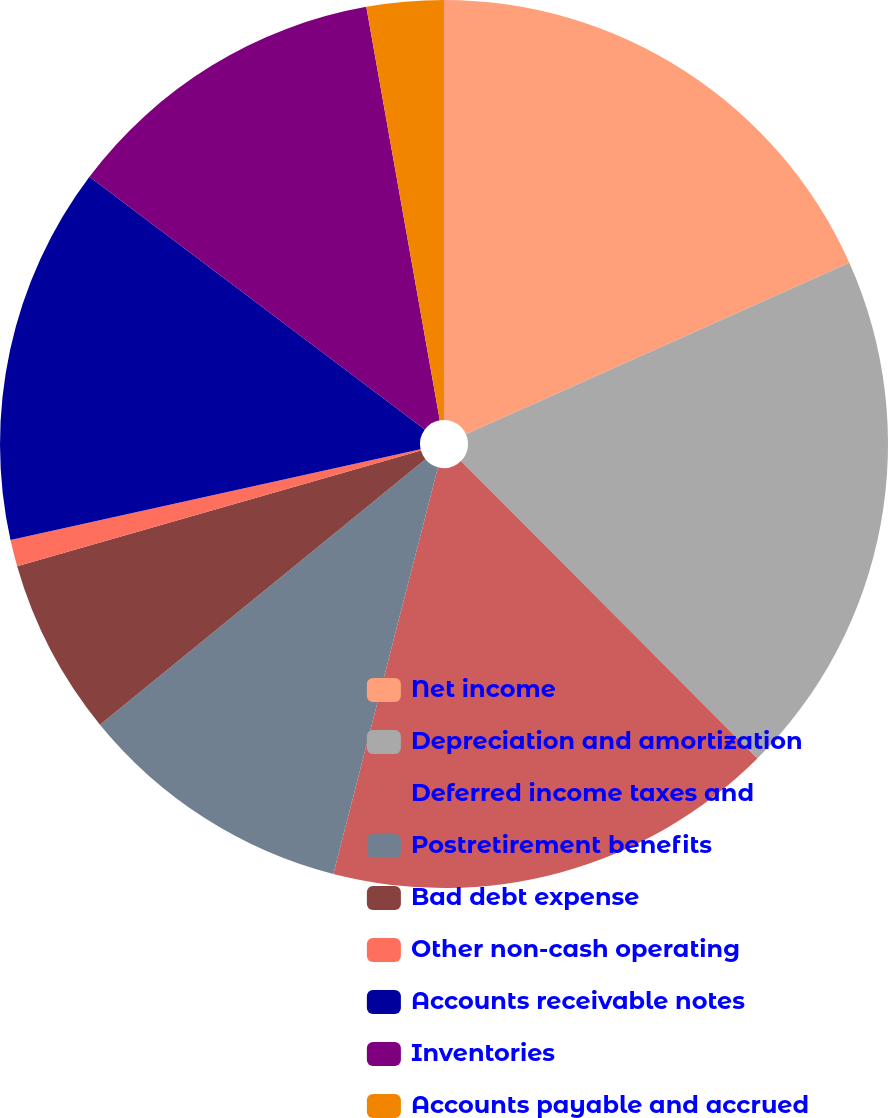Convert chart to OTSL. <chart><loc_0><loc_0><loc_500><loc_500><pie_chart><fcel>Net income<fcel>Depreciation and amortization<fcel>Deferred income taxes and<fcel>Postretirement benefits<fcel>Bad debt expense<fcel>Other non-cash operating<fcel>Accounts receivable notes<fcel>Inventories<fcel>Accounts payable and accrued<nl><fcel>18.31%<fcel>19.22%<fcel>16.48%<fcel>10.1%<fcel>6.45%<fcel>0.97%<fcel>13.75%<fcel>11.92%<fcel>2.8%<nl></chart> 